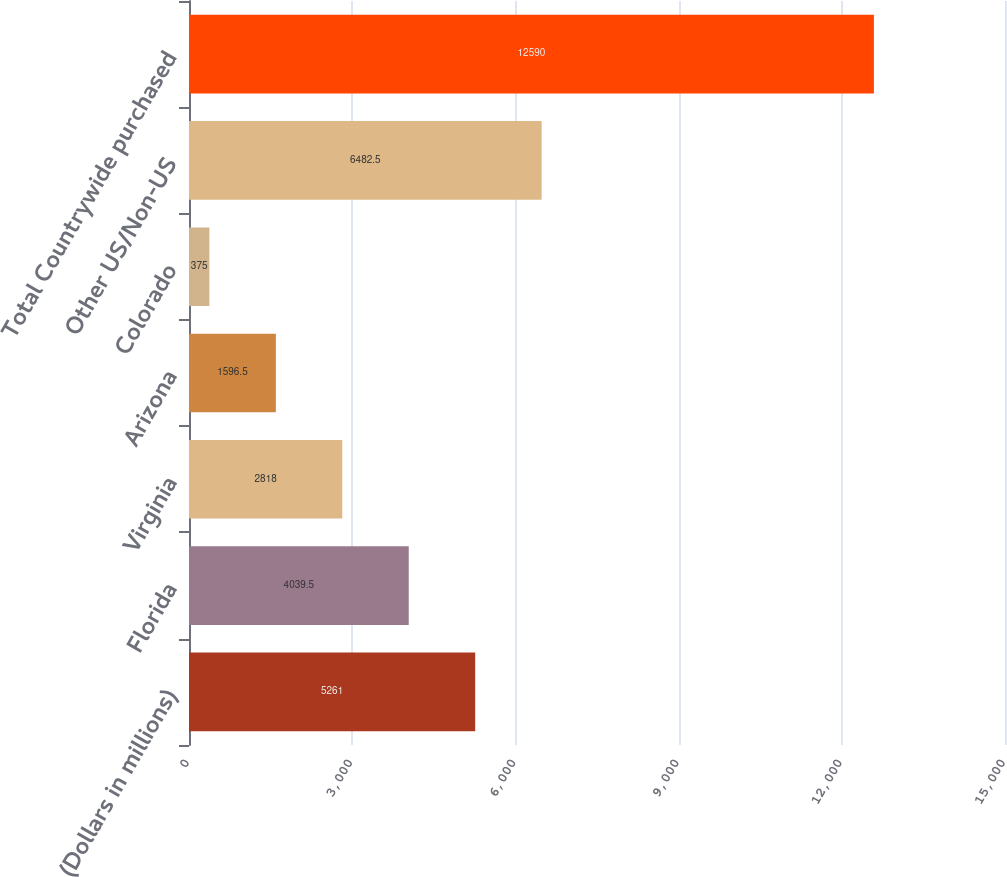Convert chart. <chart><loc_0><loc_0><loc_500><loc_500><bar_chart><fcel>(Dollars in millions)<fcel>Florida<fcel>Virginia<fcel>Arizona<fcel>Colorado<fcel>Other US/Non-US<fcel>Total Countrywide purchased<nl><fcel>5261<fcel>4039.5<fcel>2818<fcel>1596.5<fcel>375<fcel>6482.5<fcel>12590<nl></chart> 